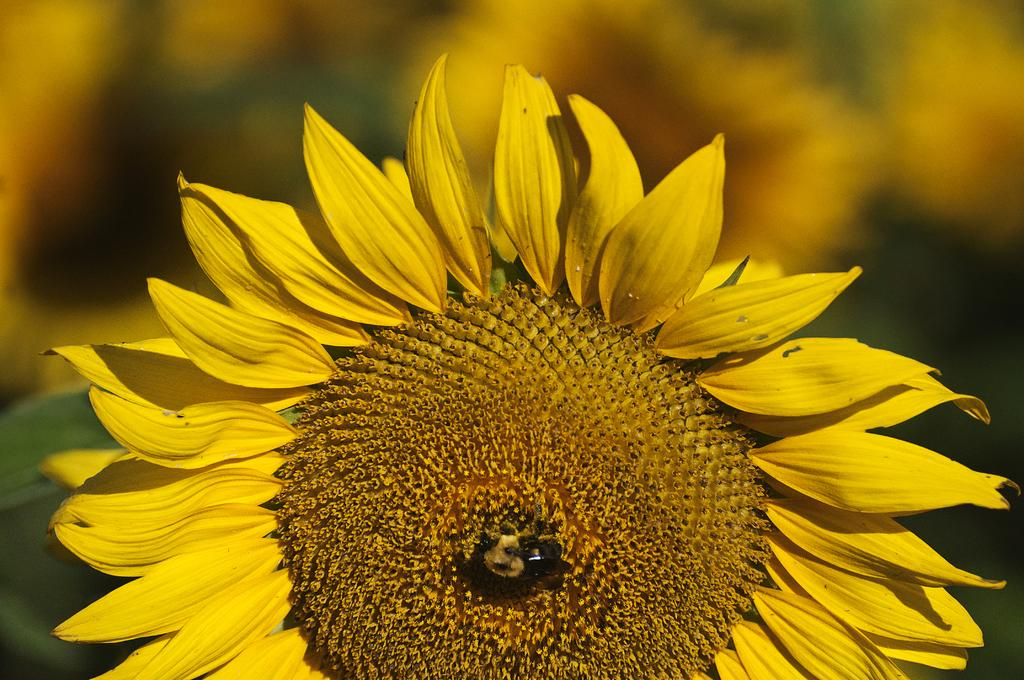What type of flower is in the image? There is a sunflower in the image. What color is the sunflower? The sunflower is yellow in color. How would you describe the background of the image? The background of the image is blurry. What colors can be seen in the background of the image? The background colors include yellow, black, green, and brown. What causes the worm to sneeze in the image? There is no worm or sneezing in the image; it features a sunflower with a blurry background. 